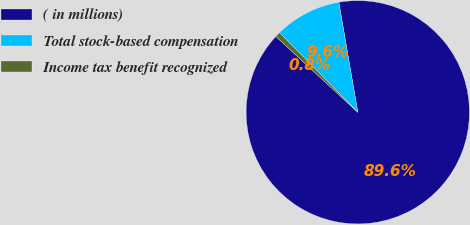Convert chart to OTSL. <chart><loc_0><loc_0><loc_500><loc_500><pie_chart><fcel>( in millions)<fcel>Total stock-based compensation<fcel>Income tax benefit recognized<nl><fcel>89.6%<fcel>9.64%<fcel>0.76%<nl></chart> 